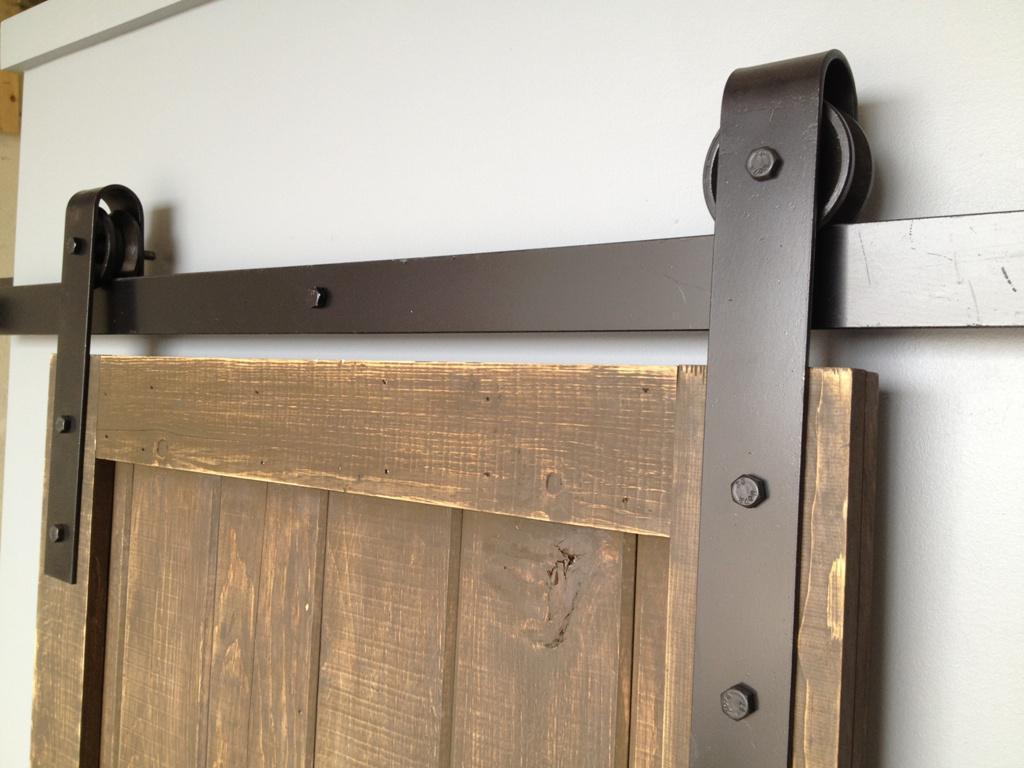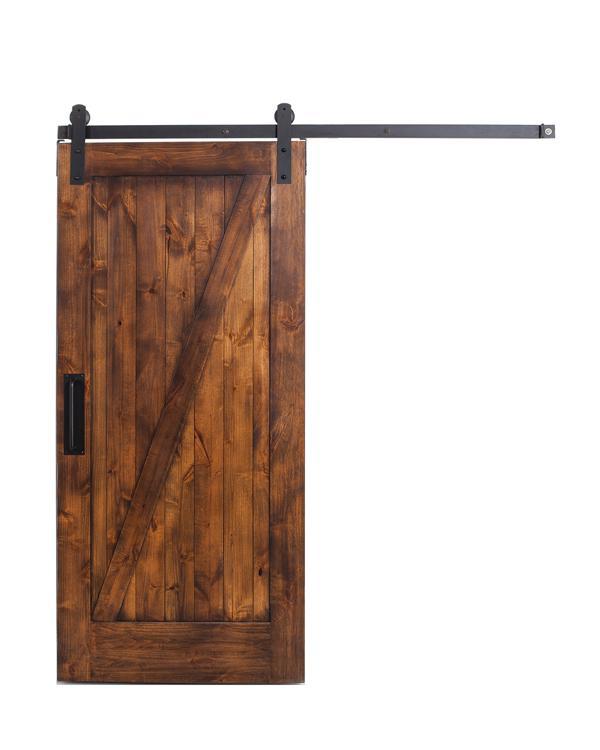The first image is the image on the left, the second image is the image on the right. Assess this claim about the two images: "A door is mirrored.". Correct or not? Answer yes or no. No. The first image is the image on the left, the second image is the image on the right. Assess this claim about the two images: "There are three doors.". Correct or not? Answer yes or no. No. 